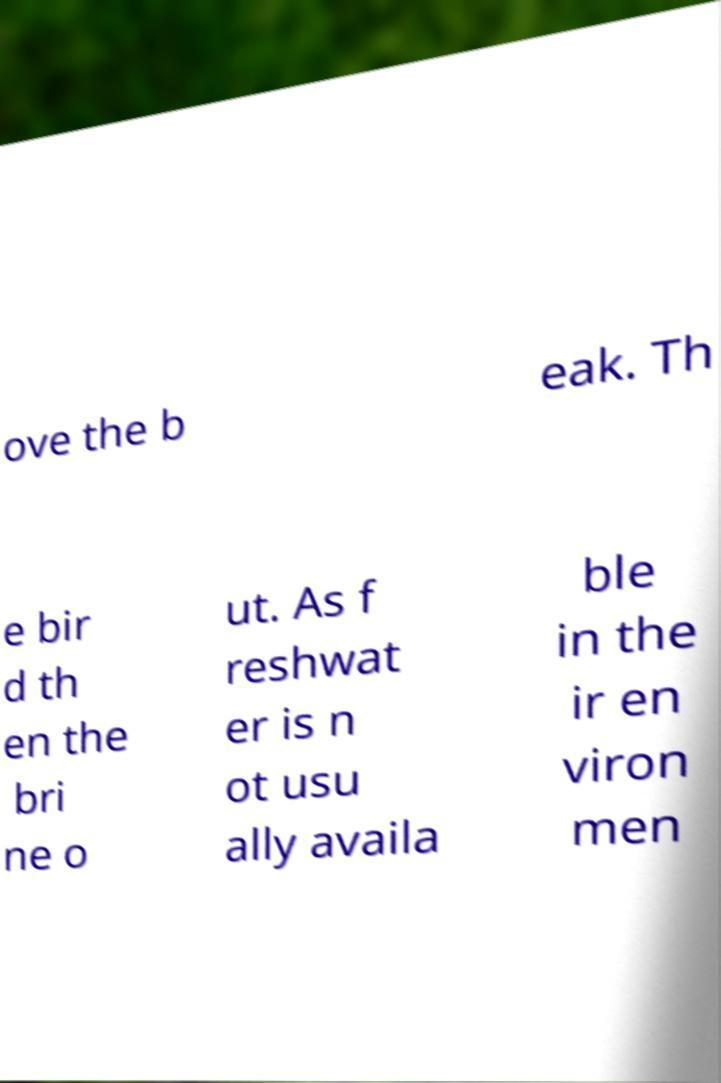Can you read and provide the text displayed in the image?This photo seems to have some interesting text. Can you extract and type it out for me? ove the b eak. Th e bir d th en the bri ne o ut. As f reshwat er is n ot usu ally availa ble in the ir en viron men 